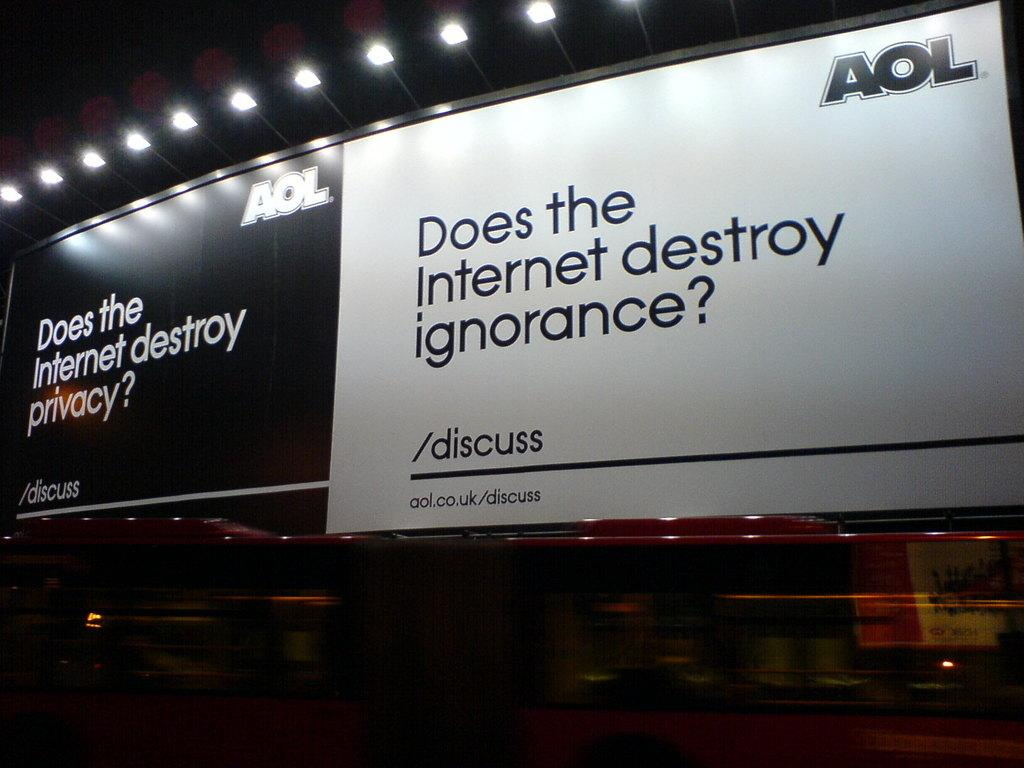What is the main object in the image? There is a billboard in the image. What can be seen on the billboard? The billboard has text on it. Are there any additional features on the billboard? Yes, there are lamps on top of the billboard. What is located near the bottom of the billboard? There is a bus at the bottom of the billboard. What type of scarf is draped over the bus in the image? There is no scarf present in the image; it only features a billboard with text, lamps, and a bus. 